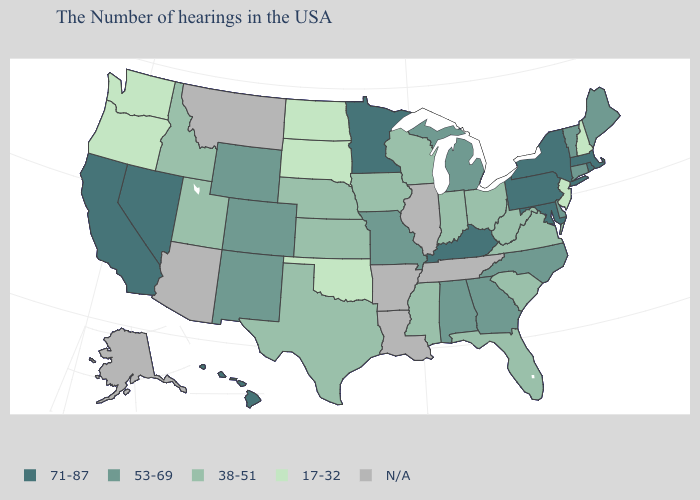Which states have the lowest value in the Northeast?
Short answer required. New Hampshire, New Jersey. Which states have the lowest value in the South?
Concise answer only. Oklahoma. Does Nevada have the highest value in the West?
Be succinct. Yes. Which states have the lowest value in the USA?
Concise answer only. New Hampshire, New Jersey, Oklahoma, South Dakota, North Dakota, Washington, Oregon. What is the lowest value in states that border North Carolina?
Concise answer only. 38-51. What is the value of California?
Keep it brief. 71-87. Name the states that have a value in the range N/A?
Give a very brief answer. Tennessee, Illinois, Louisiana, Arkansas, Montana, Arizona, Alaska. Among the states that border New Jersey , which have the highest value?
Answer briefly. New York, Pennsylvania. What is the lowest value in states that border Massachusetts?
Write a very short answer. 17-32. What is the value of Maryland?
Concise answer only. 71-87. Does the map have missing data?
Answer briefly. Yes. Among the states that border Utah , which have the highest value?
Keep it brief. Nevada. Name the states that have a value in the range 53-69?
Answer briefly. Maine, Vermont, Connecticut, Delaware, North Carolina, Georgia, Michigan, Alabama, Missouri, Wyoming, Colorado, New Mexico. Among the states that border Colorado , does Oklahoma have the lowest value?
Short answer required. Yes. 